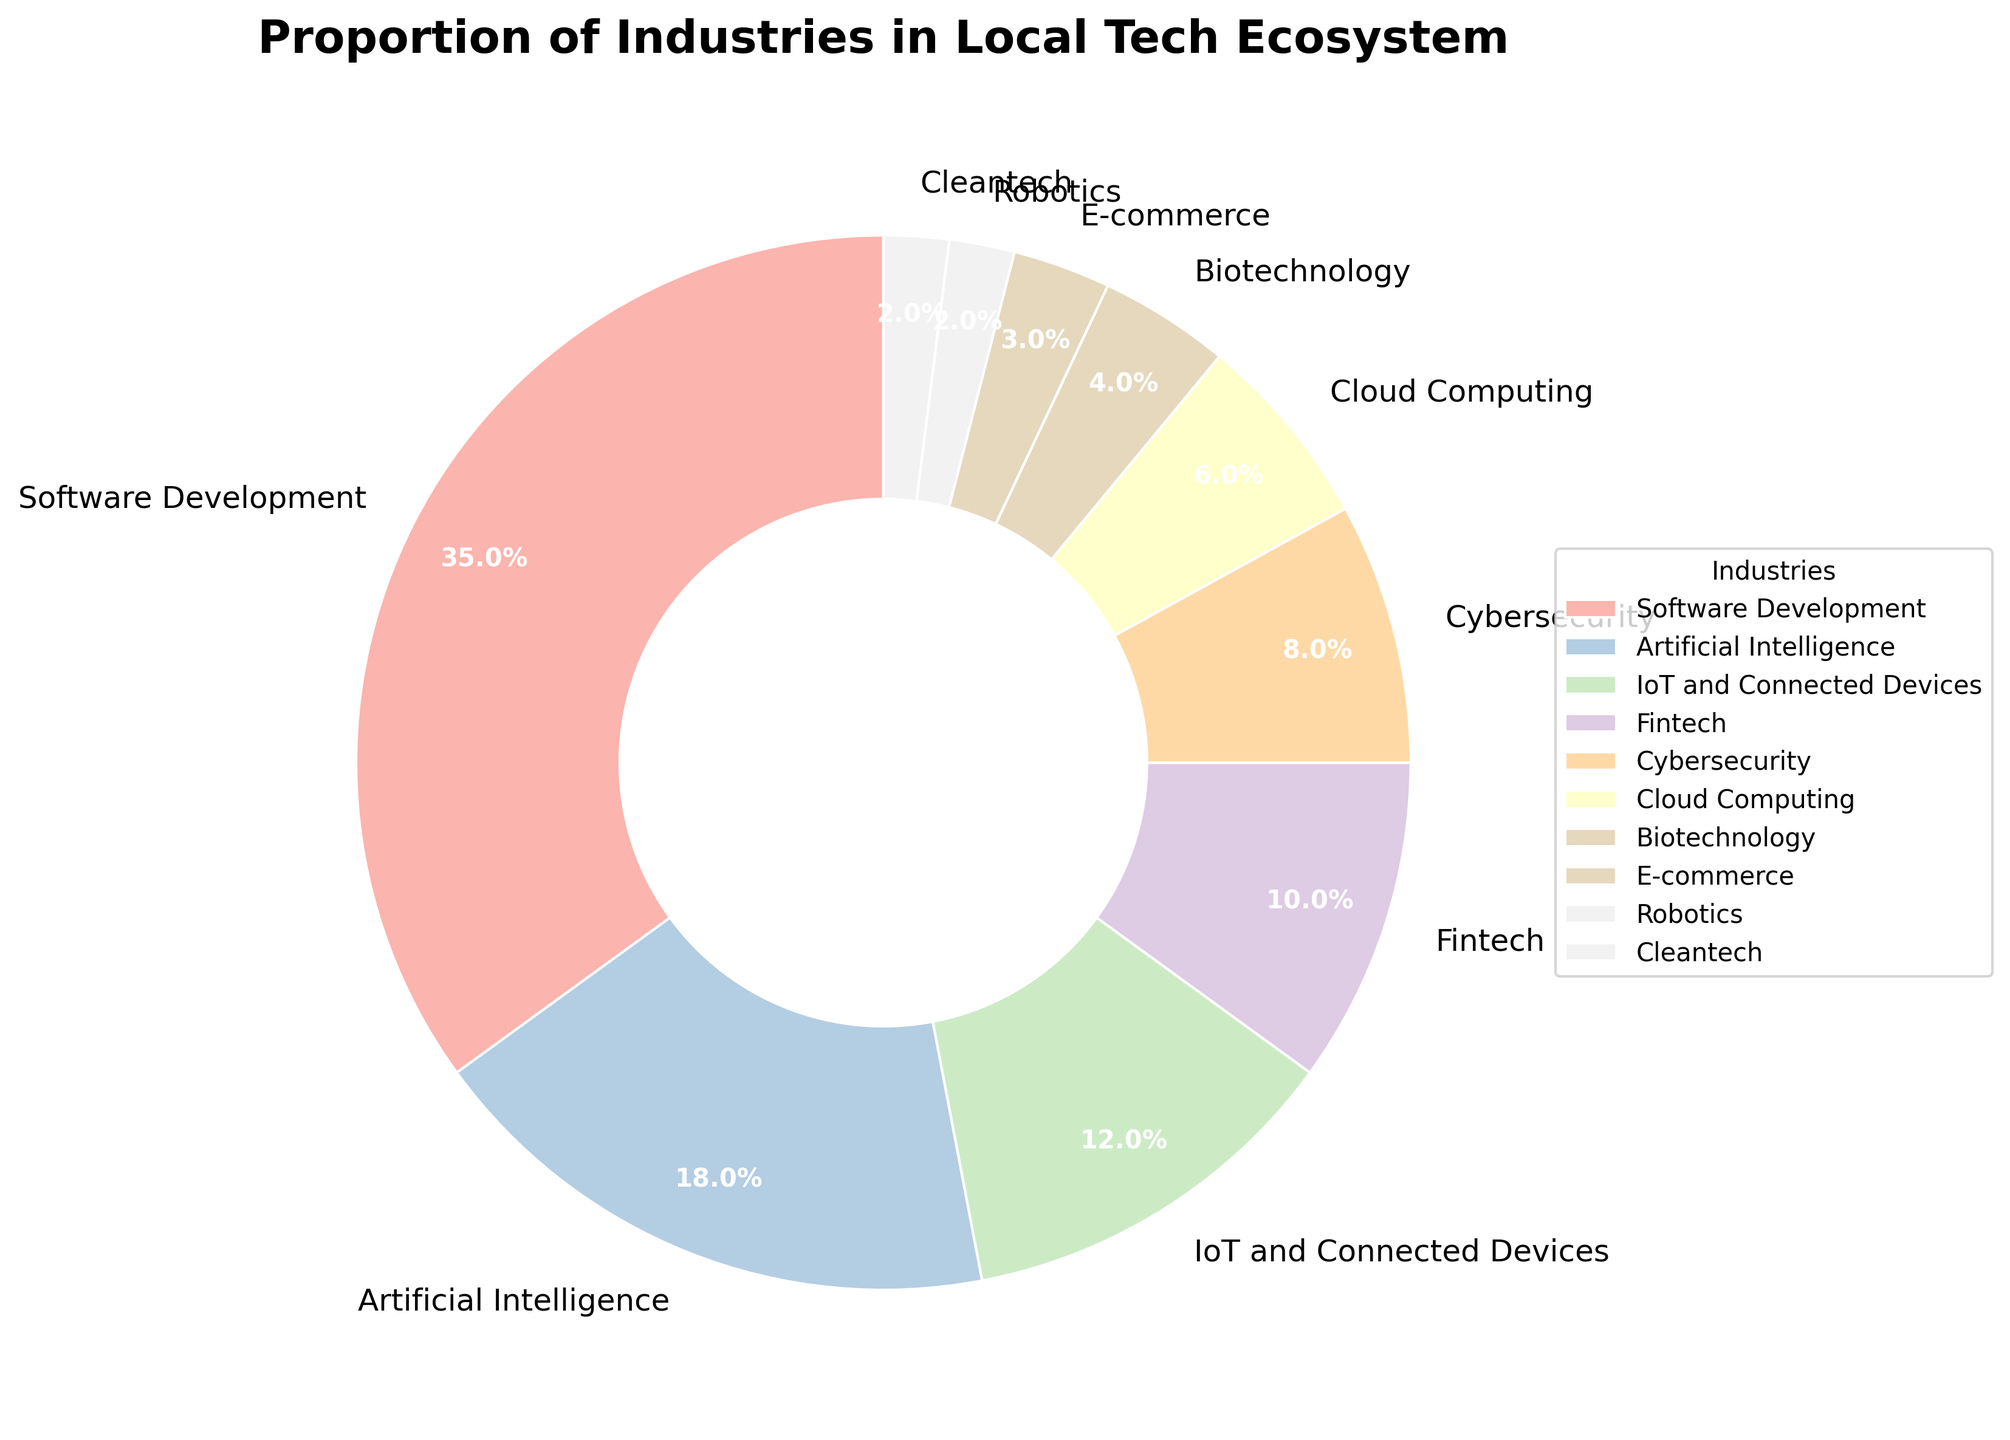What is the industry with the highest proportion? The largest segment in the pie chart represents Software Development. It takes up 35% of the total proportion.
Answer: Software Development How much more percentage does Software Development have compared to Artificial Intelligence? Software Development has 35% and Artificial Intelligence has 18%. The difference is 35% - 18% = 17%.
Answer: 17% Which industries have a smaller proportion than Fintech? The industries with smaller proportions than Fintech (10%) include Cybersecurity (8%), Cloud Computing (6%), Biotechnology (4%), E-commerce (3%), Robotics (2%), and Cleantech (2%).
Answer: Cybersecurity, Cloud Computing, Biotechnology, E-commerce, Robotics, Cleantech What is the combined proportion of IoT and Connected Devices, and Fintech? The proportion for IoT and Connected Devices is 12%, and for Fintech is 10%. The combined proportion is 12% + 10% = 22%.
Answer: 22% How many industries have a proportion greater than 10%? By observing the pie chart, the industries with a proportion greater than 10% are Software Development (35%), Artificial Intelligence (18%), and IoT and Connected Devices (12%). There are 3 such industries.
Answer: 3 Which two industries combined have the same proportion as Software Development? Artificial Intelligence has 18% and Cybersecurity has 8%. Their combined proportion is 18% + 8% = 26%, which is not sufficient. However, IoT and Connected Devices has 12% and Fintech has 10%. Their sum is 12% + 10% = 22%, which still does not match. Artificial Intelligence and IoT and Connected Devices have 18% + 12% = 30%. Still not sufficient. Therefore, there aren't two exact industries that sum to Software Development's 35%, but Artificial Intelligence and Fintech combined is the closest at 28%.
Answer: None exactly What is the dominant color in the pie chart? The dominant section of the pie chart is for Software Development which typically is shown with a specific color from the pastel palette. However, the color information is abstracted here, so it would need to be visually identified from the chart.
Answer: Cannot be answered explicitly without visual Which two industries together only make up 4% of the ecosystem? The industries making up 4% together are those in the lower proportions. Both Robotics and Cleantech each have 2%, making their combined contribution 2% + 2% = 4%.
Answer: Robotics and Cleantech What is the total proportion of industries related to data and security (including Artificial Intelligence, Cybersecurity, and Cloud Computing)? Add the percentages of Artificial Intelligence (18%), Cybersecurity (8%), and Cloud Computing (6%). The total is 18% + 8% + 6% = 32%.
Answer: 32% Is the proportion of E-commerce greater than that of Robotics? From the chart, E-commerce is 3% while Robotics is 2%. Therefore, E-commerce proportion is greater than Robotics.
Answer: Yes 